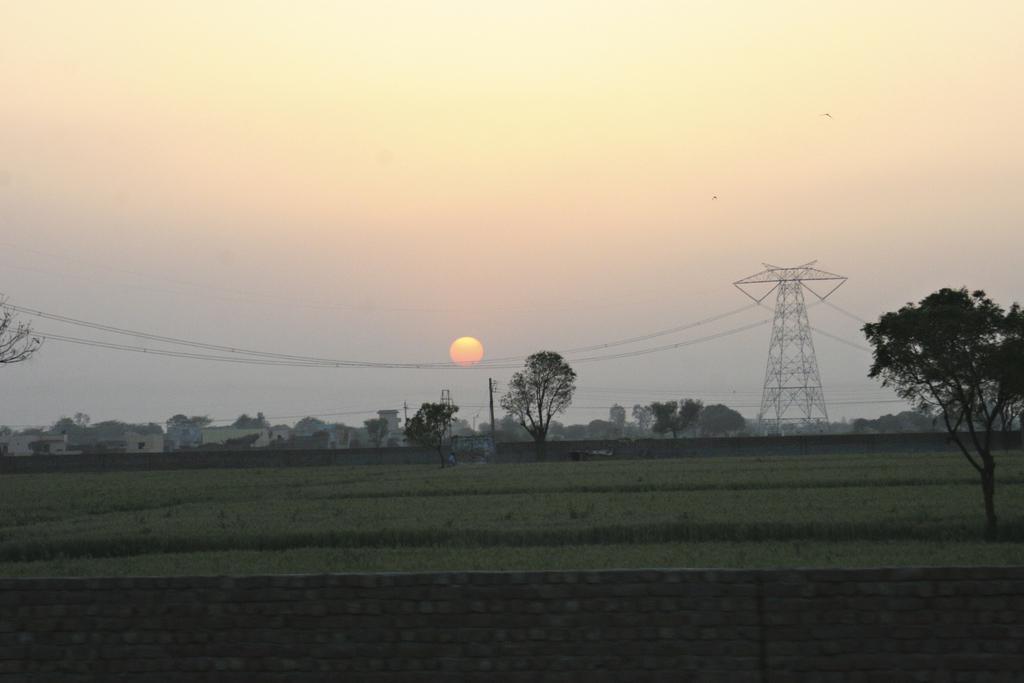Describe this image in one or two sentences. In this picture we can see a wall, beside this wall we can see grass on the ground, here we can see buildings, trees, electric poles and some objects and in the background we can see sky, sun. 